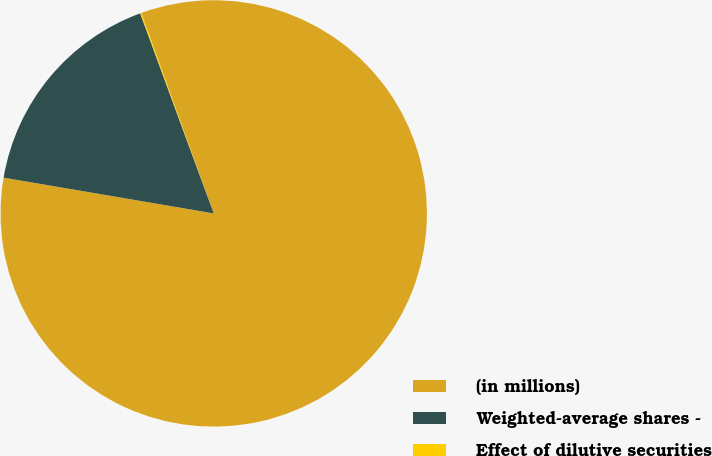Convert chart. <chart><loc_0><loc_0><loc_500><loc_500><pie_chart><fcel>(in millions)<fcel>Weighted-average shares -<fcel>Effect of dilutive securities<nl><fcel>83.2%<fcel>16.71%<fcel>0.09%<nl></chart> 